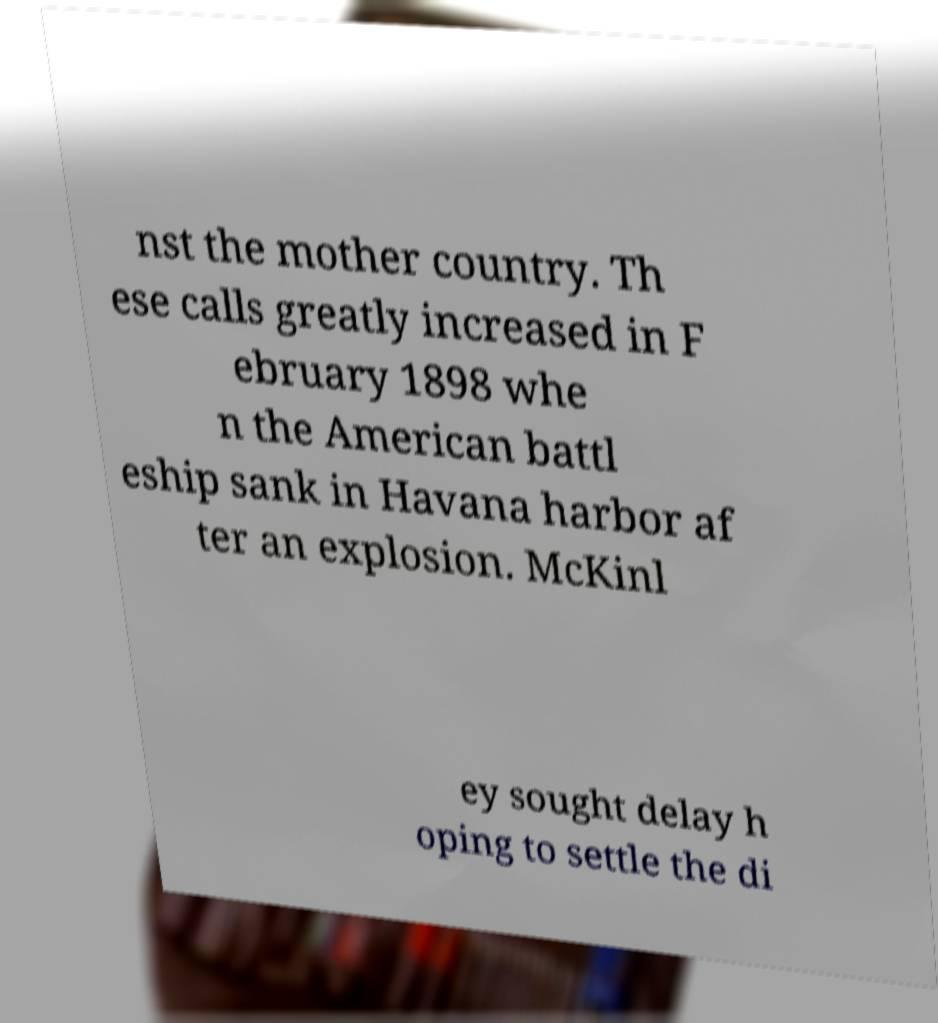Can you read and provide the text displayed in the image?This photo seems to have some interesting text. Can you extract and type it out for me? nst the mother country. Th ese calls greatly increased in F ebruary 1898 whe n the American battl eship sank in Havana harbor af ter an explosion. McKinl ey sought delay h oping to settle the di 